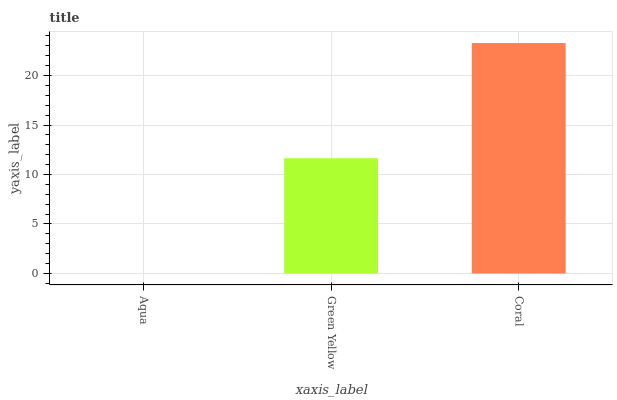Is Aqua the minimum?
Answer yes or no. Yes. Is Coral the maximum?
Answer yes or no. Yes. Is Green Yellow the minimum?
Answer yes or no. No. Is Green Yellow the maximum?
Answer yes or no. No. Is Green Yellow greater than Aqua?
Answer yes or no. Yes. Is Aqua less than Green Yellow?
Answer yes or no. Yes. Is Aqua greater than Green Yellow?
Answer yes or no. No. Is Green Yellow less than Aqua?
Answer yes or no. No. Is Green Yellow the high median?
Answer yes or no. Yes. Is Green Yellow the low median?
Answer yes or no. Yes. Is Aqua the high median?
Answer yes or no. No. Is Coral the low median?
Answer yes or no. No. 